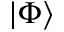<formula> <loc_0><loc_0><loc_500><loc_500>\left | \Phi \right \rangle</formula> 